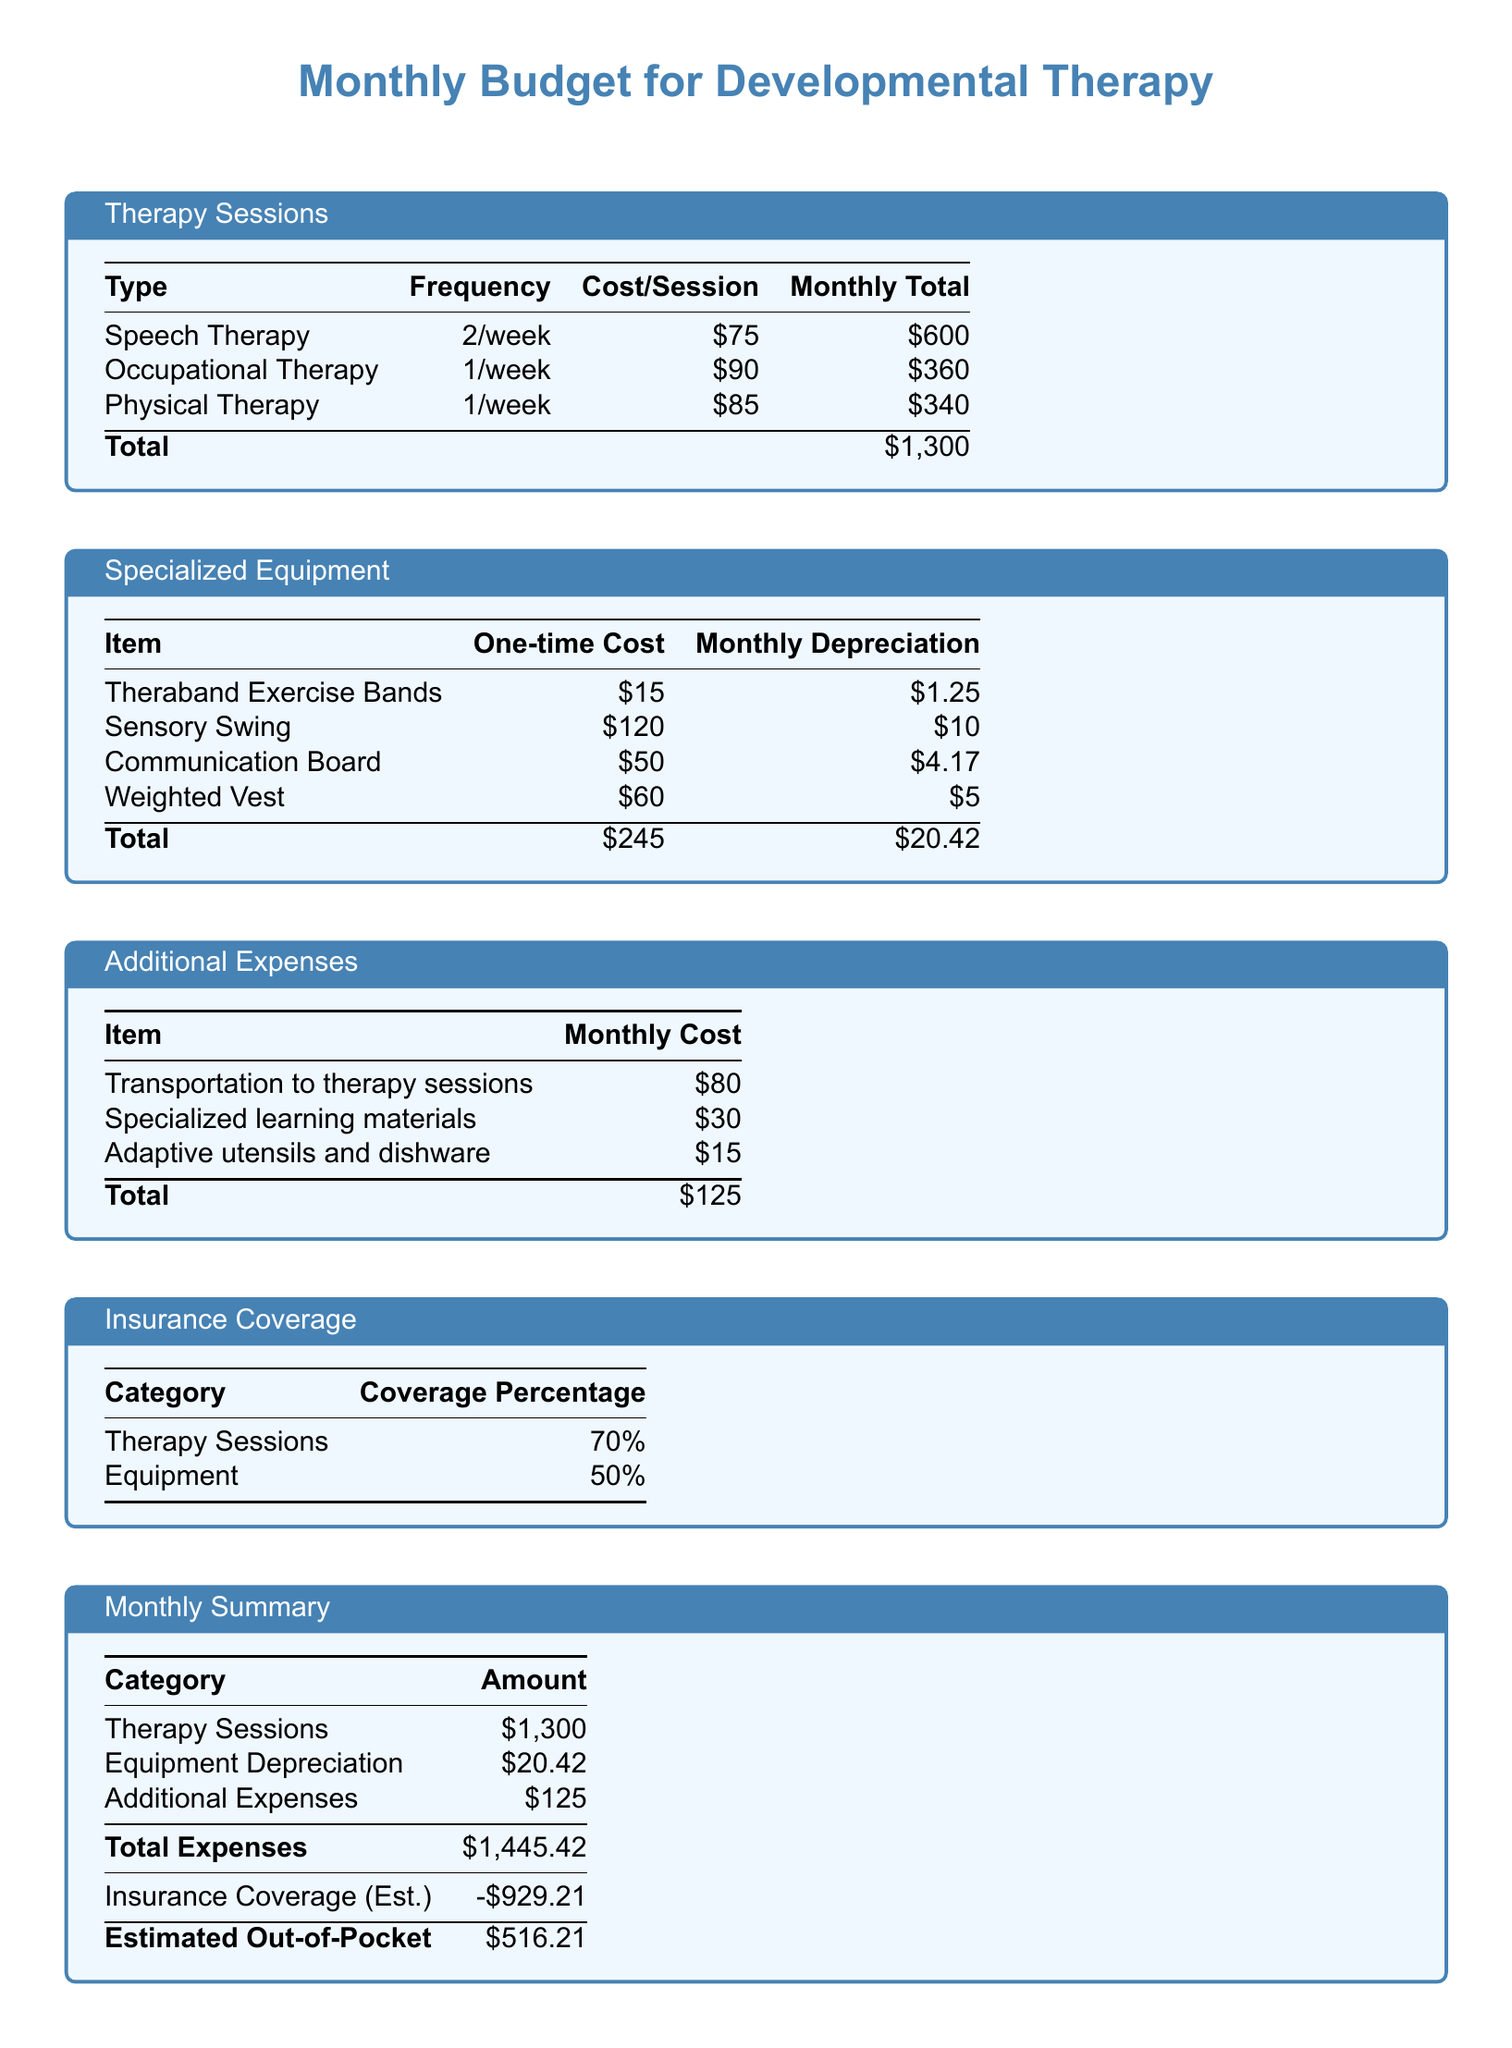What is the total cost of speech therapy sessions per month? The total cost of speech therapy sessions per month is calculated by multiplying the frequency by the cost per session, which is 2 times $75 = $150.
Answer: $600 What is the one-time cost of the sensory swing? The one-time cost of the sensory swing is clearly listed in the budget.
Answer: $120 How much is the monthly cost for adaptive utensils and dishware? The monthly cost for adaptive utensils and dishware is specified under additional expenses.
Answer: $15 What percentage of therapy sessions is covered by insurance? The insurance coverage percentage for therapy sessions is found in the insurance coverage section.
Answer: 70% What is the estimated out-of-pocket expense for the month? The estimated out-of-pocket expense is calculated by deducting the insurance coverage from total expenses, which gives $1,445.42 - $929.21.
Answer: $516.21 How much is the cost for transportation to therapy sessions? The cost for transportation to therapy sessions is specifically listed in the additional expenses table.
Answer: $80 What is the total monthly cost for specialized equipment depreciation? The total monthly cost for specialized equipment depreciation is provided in the equipment section of the budget.
Answer: $20.42 What is the frequency of occupational therapy sessions? The frequency of occupational therapy sessions is specified in the therapy sessions table.
Answer: 1/week What is the total monthly cost for all therapy sessions combined? The total monthly cost for all therapy sessions is the sum of individual therapy costs listed in the document.
Answer: $1,300 